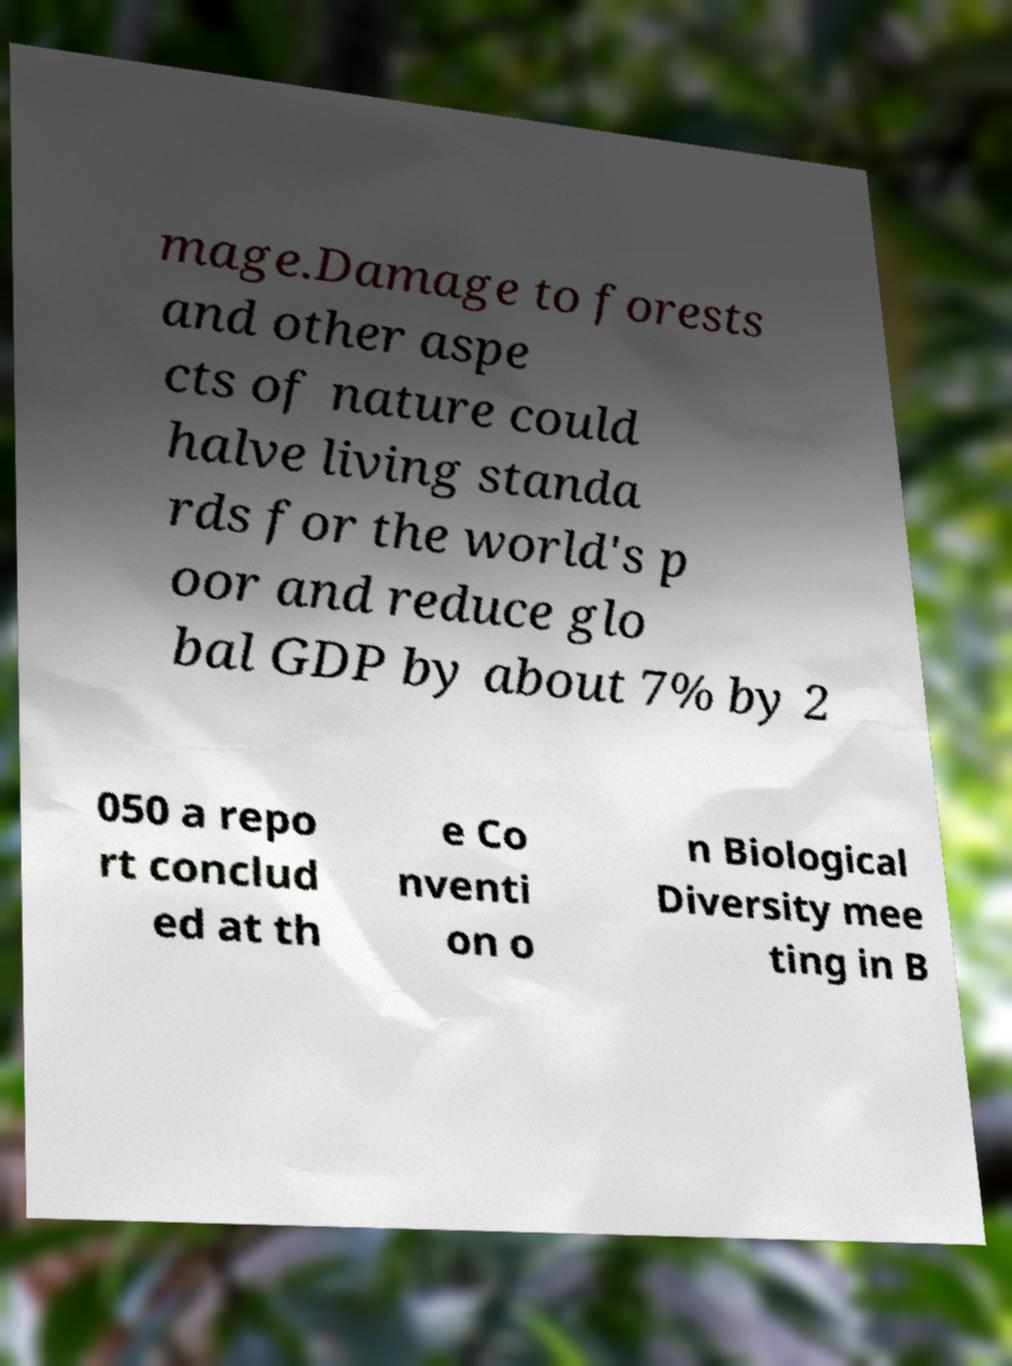For documentation purposes, I need the text within this image transcribed. Could you provide that? mage.Damage to forests and other aspe cts of nature could halve living standa rds for the world's p oor and reduce glo bal GDP by about 7% by 2 050 a repo rt conclud ed at th e Co nventi on o n Biological Diversity mee ting in B 